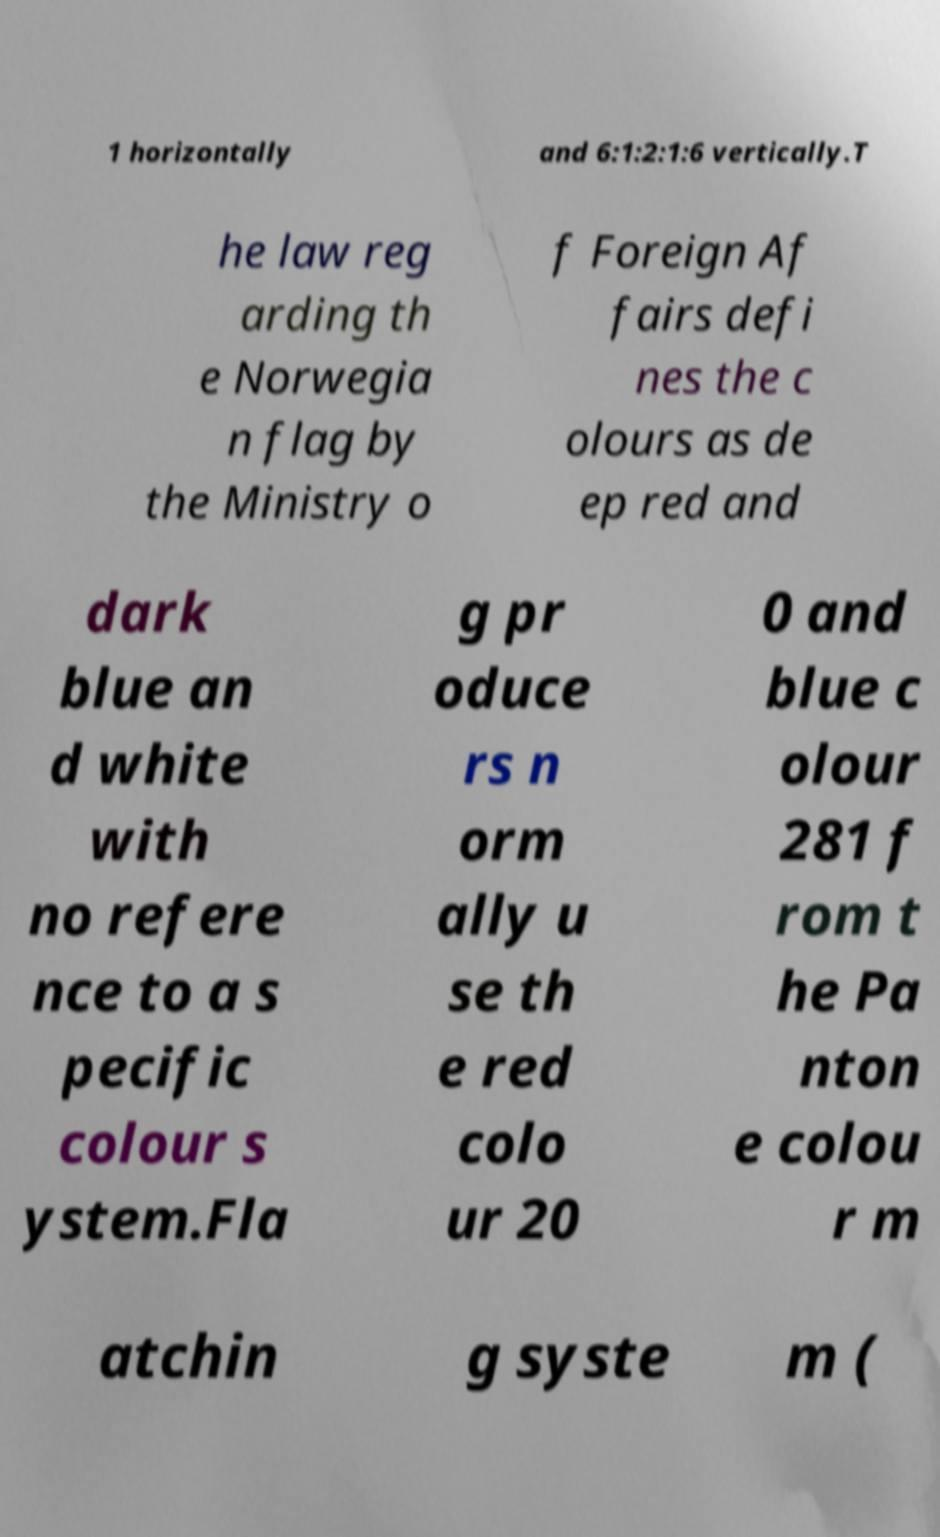Can you accurately transcribe the text from the provided image for me? 1 horizontally and 6:1:2:1:6 vertically.T he law reg arding th e Norwegia n flag by the Ministry o f Foreign Af fairs defi nes the c olours as de ep red and dark blue an d white with no refere nce to a s pecific colour s ystem.Fla g pr oduce rs n orm ally u se th e red colo ur 20 0 and blue c olour 281 f rom t he Pa nton e colou r m atchin g syste m ( 